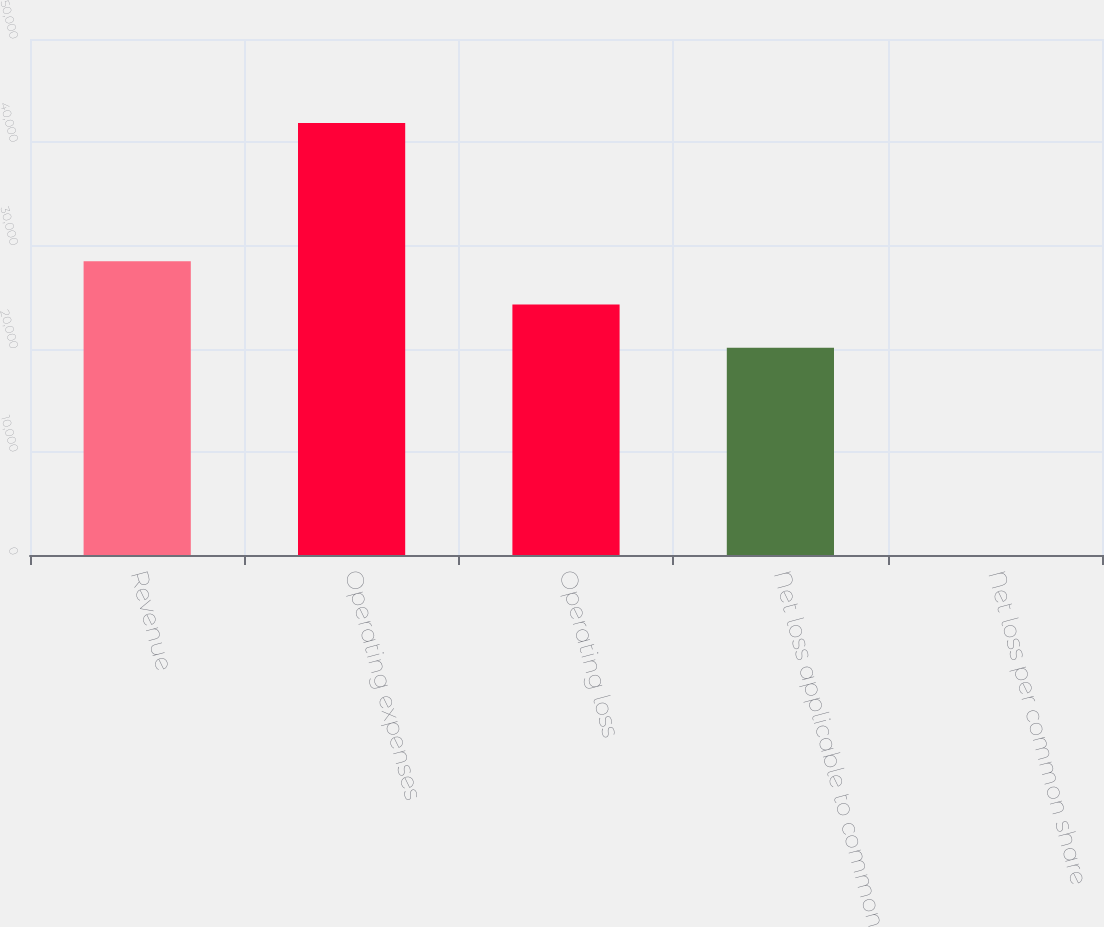Convert chart. <chart><loc_0><loc_0><loc_500><loc_500><bar_chart><fcel>Revenue<fcel>Operating expenses<fcel>Operating loss<fcel>Net loss applicable to common<fcel>Net loss per common share<nl><fcel>28453.9<fcel>41850<fcel>24268.9<fcel>20084<fcel>0.55<nl></chart> 